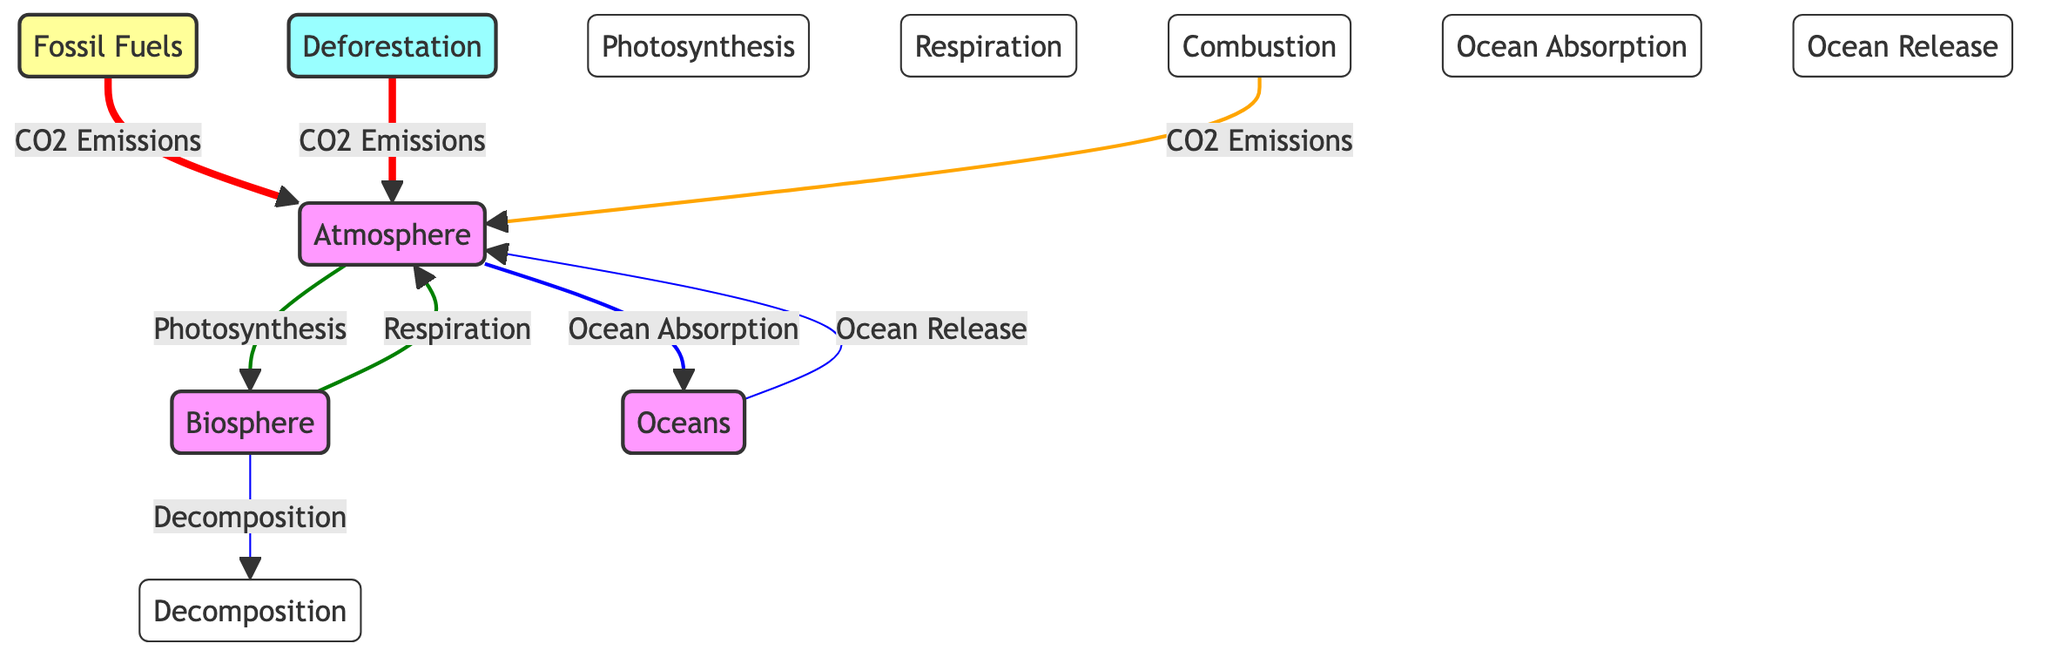What are the main components of the carbon cycle shown in the diagram? The diagram includes three key components: Atmosphere, Biosphere, and Oceans, which are all labeled and represented in connection with various processes related to the carbon cycle.
Answer: Atmosphere, Biosphere, Oceans Which process directly transfers carbon from the Biosphere to the Atmosphere? The process that transfers carbon from the Biosphere to the Atmosphere is Respiration, as indicated by the arrow flowing from Biosphere to Atmosphere labeled with Respiration.
Answer: Respiration What is the thickness of the arrow representing CO2 emissions from Deforestation? The thickness of the arrow representing CO2 emissions from Deforestation to the Atmosphere is 4px, which is shown by the link styles defined in the diagram indicating its significance.
Answer: 4px How many processes are involved in transferring carbon within the diagram? In the diagram, there are five processes involved in transferring carbon: Photosynthesis, Respiration, Decomposition, Combustion, and Ocean Absorption, which can be counted based on the labeled processes connected by arrows.
Answer: 5 What effect does Combustion have on the carbon cycle according to the diagram? Combustion contributes to CO2 emissions to the Atmosphere, as shown by the arrow from Combustion to the Atmosphere with the label CO2 Emissions.
Answer: CO2 Emissions Which component absorbs carbon from the atmosphere as depicted in the diagram? The Oceans component absorbs carbon from the atmosphere, as indicated by the arrow directed towards Oceans labeled Ocean Absorption.
Answer: Oceans What is the relationship between Ocean Release and the Atmosphere in the carbon cycle? Ocean Release emits carbon dioxide into the Atmosphere, as indicated by the arrow flowing from Oceans to Atmosphere tagged with Ocean Release, showing a direct relationship.
Answer: Emits CO2 What is the direction of carbon flow from Fossil Fuels in the diagram? The flow of carbon from Fossil Fuels is directed towards the Atmosphere, demonstrated by the arrow leading from Fossil Fuels to Atmosphere labeled with CO2 Emissions.
Answer: Towards Atmosphere How does Deforestation impact the carbon cycle according to the diagram? Deforestation impacts the carbon cycle by adding CO2 emissions to the Atmosphere, as shown by the arrow from Deforestation to the Atmosphere labeled with CO2 Emissions, indicating a negative effect.
Answer: Adds CO2 Emissions 